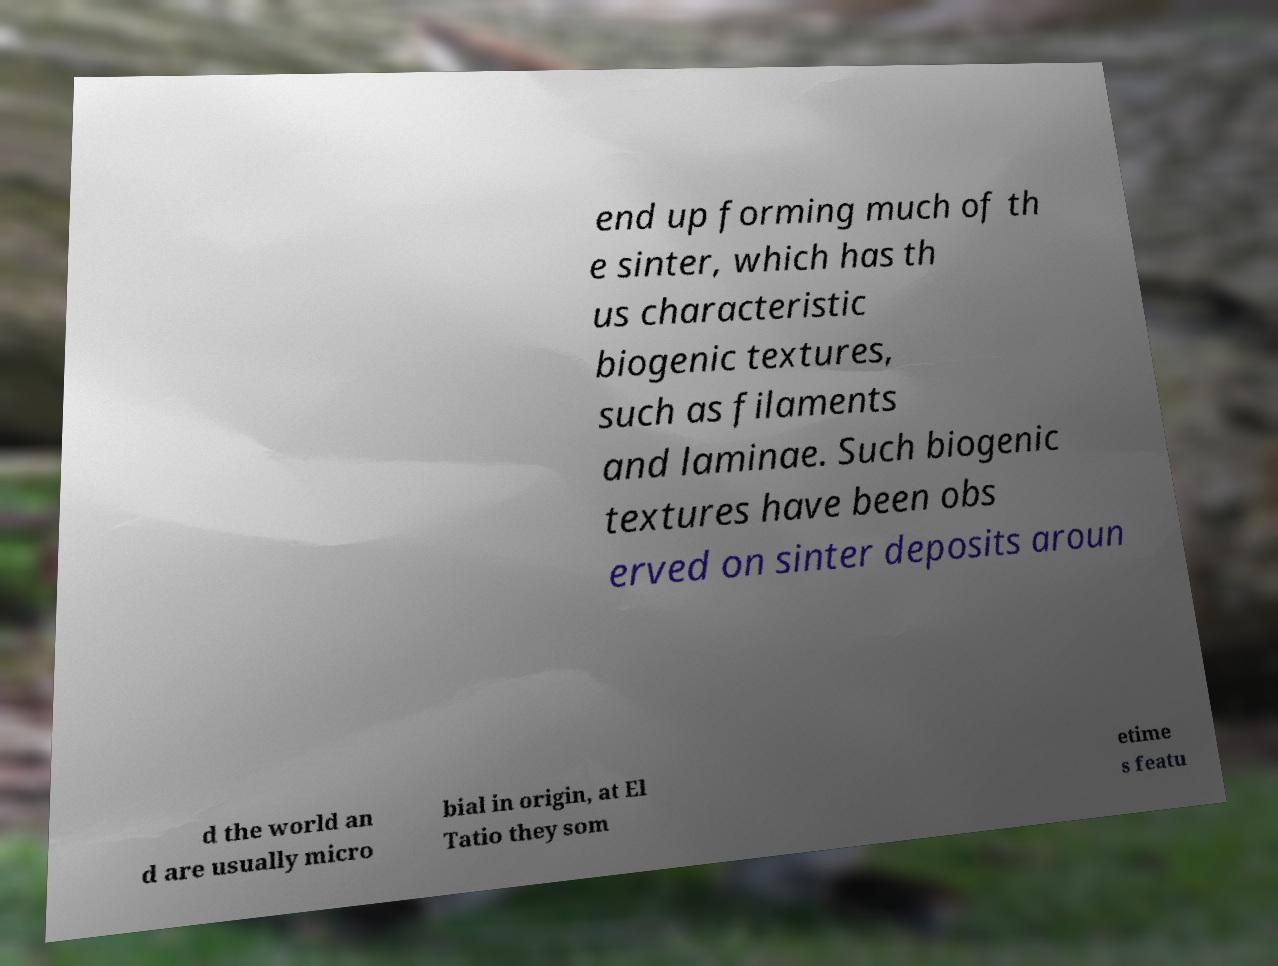What messages or text are displayed in this image? I need them in a readable, typed format. end up forming much of th e sinter, which has th us characteristic biogenic textures, such as filaments and laminae. Such biogenic textures have been obs erved on sinter deposits aroun d the world an d are usually micro bial in origin, at El Tatio they som etime s featu 